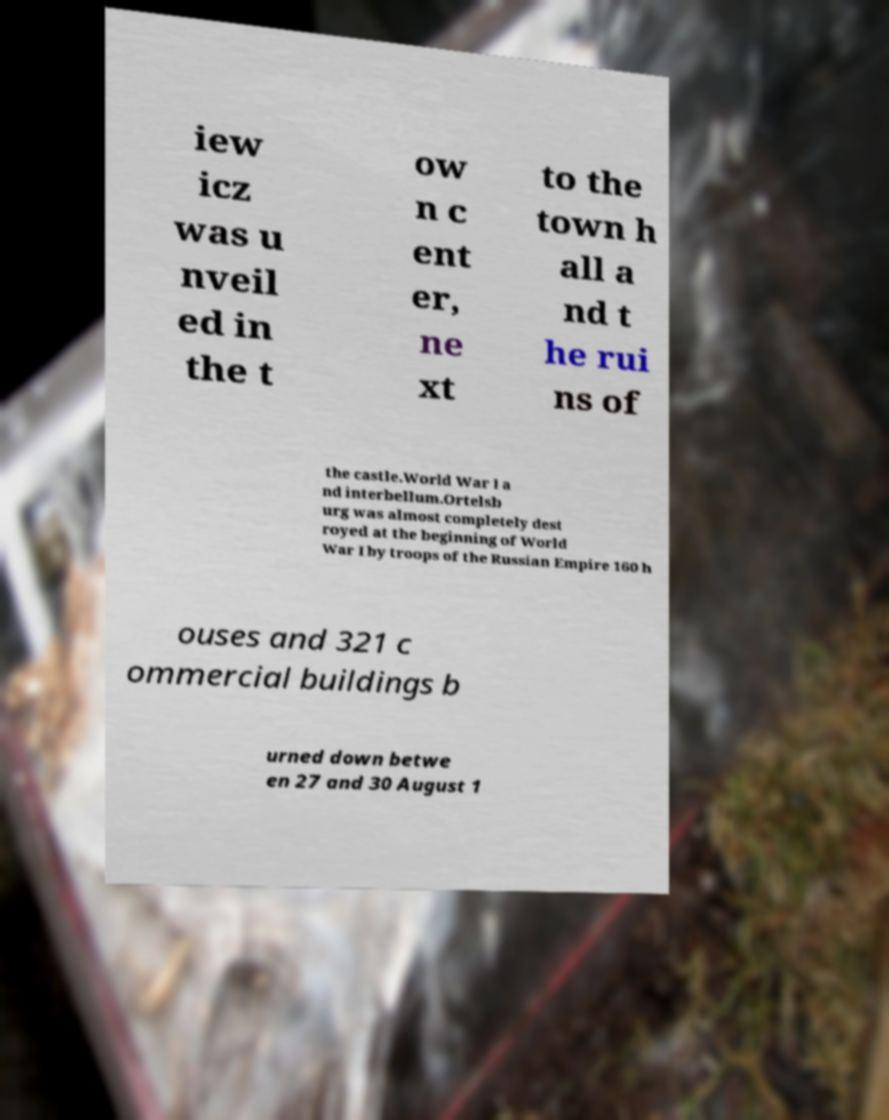Could you extract and type out the text from this image? iew icz was u nveil ed in the t ow n c ent er, ne xt to the town h all a nd t he rui ns of the castle.World War I a nd interbellum.Ortelsb urg was almost completely dest royed at the beginning of World War I by troops of the Russian Empire 160 h ouses and 321 c ommercial buildings b urned down betwe en 27 and 30 August 1 